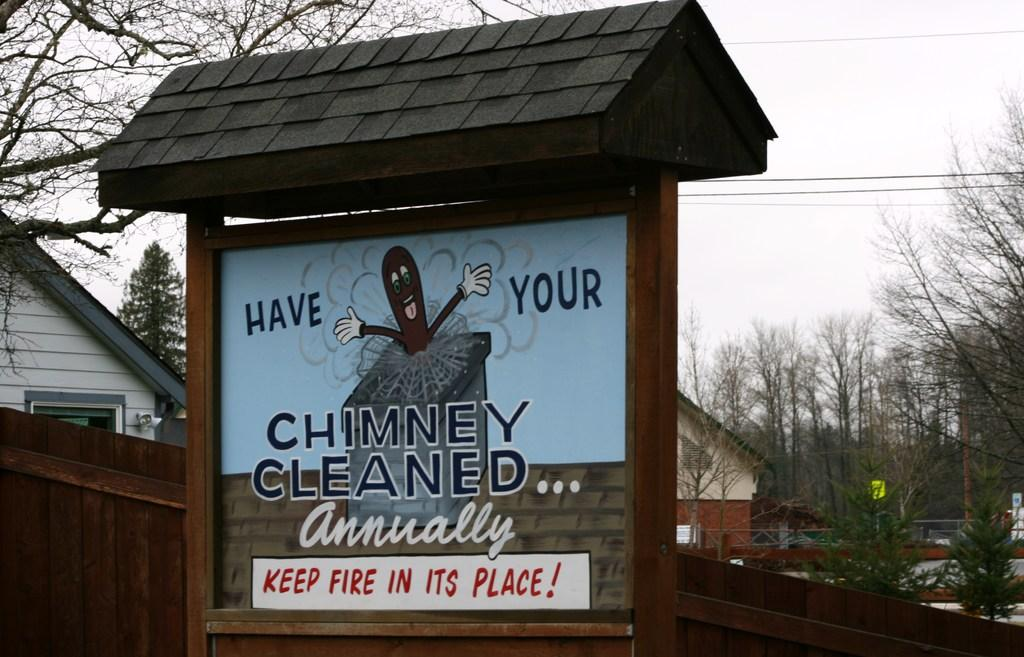What type of structures can be seen in the image? There are buildings in the image. What other natural elements are present in the image? There are trees in the image. Are there any man-made objects that are not buildings? Yes, there are wires in the image. What is the purpose of the board in the image? The board has a cartoon image on it and text written on it, which suggests it might be used for communication or displaying information. What can be seen in the background of the image? The sky is visible in the background of the image. What type of carpenter is competing in the glass-making competition in the image? There is no carpenter or glass-making competition present in the image. 